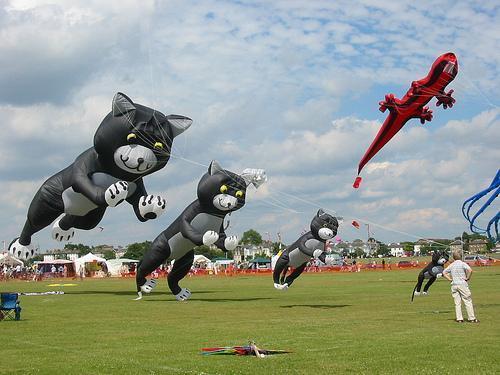How many cat balloons are there?
Give a very brief answer. 4. How many kites are there?
Give a very brief answer. 4. How many giraffes are in this photo?
Give a very brief answer. 0. 